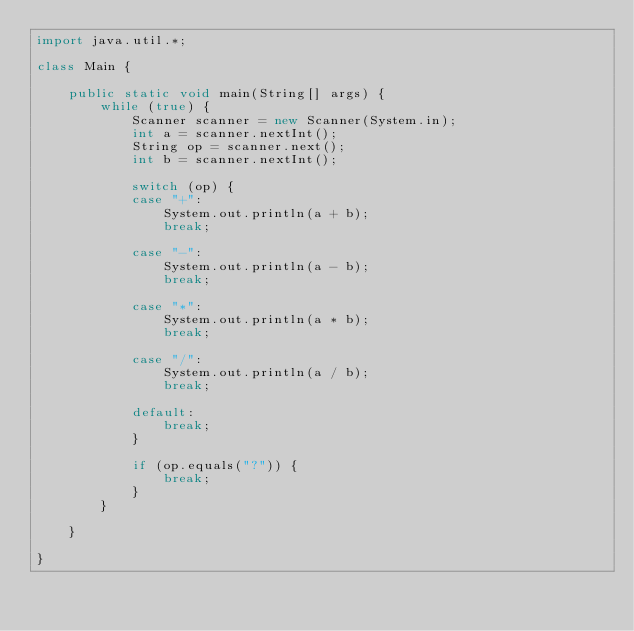Convert code to text. <code><loc_0><loc_0><loc_500><loc_500><_Java_>import java.util.*;

class Main {
    
    public static void main(String[] args) {
        while (true) {
            Scanner scanner = new Scanner(System.in);
            int a = scanner.nextInt();
            String op = scanner.next();
            int b = scanner.nextInt();
            
            switch (op) {
            case "+":
                System.out.println(a + b);
                break;

            case "-":
                System.out.println(a - b);
                break;

            case "*":
                System.out.println(a * b);
                break;

            case "/":
                System.out.println(a / b);
                break;
                
            default:
                break;
            }
            
            if (op.equals("?")) {
                break;
            }
        }
        
    }
    
}</code> 